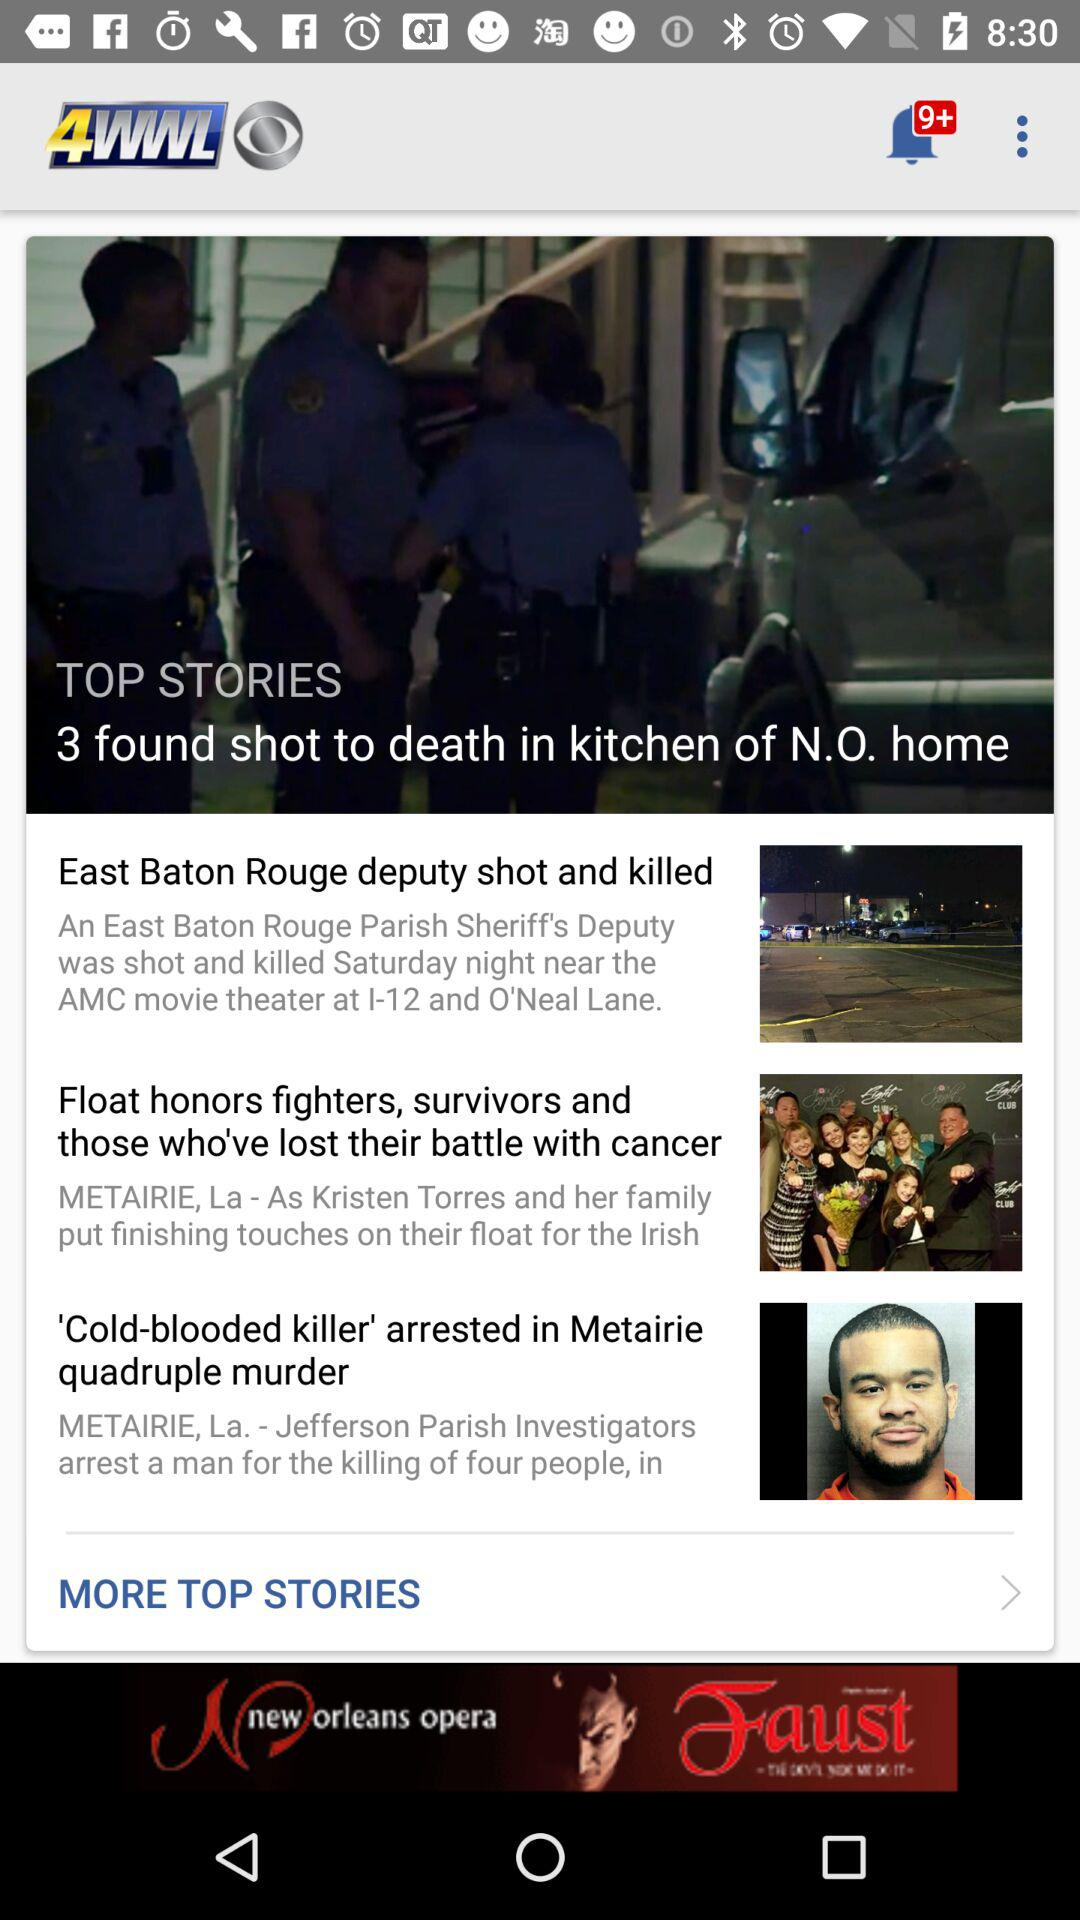How many more stories are there after the first story?
Answer the question using a single word or phrase. 2 